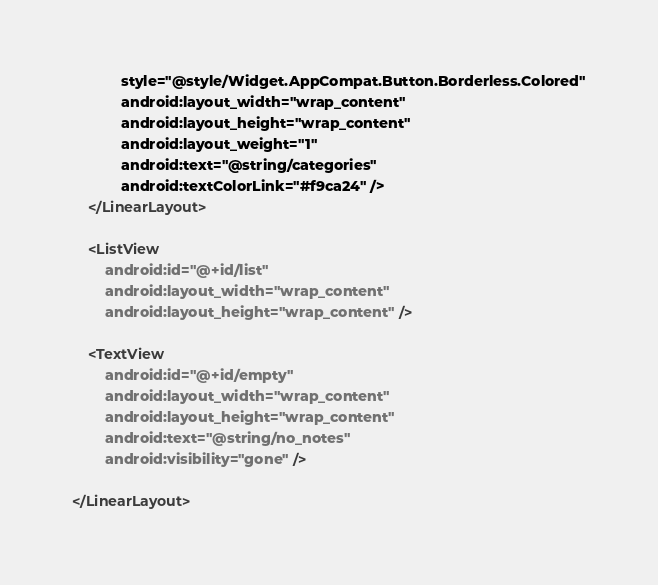<code> <loc_0><loc_0><loc_500><loc_500><_XML_>            style="@style/Widget.AppCompat.Button.Borderless.Colored"
            android:layout_width="wrap_content"
            android:layout_height="wrap_content"
            android:layout_weight="1"
            android:text="@string/categories"
            android:textColorLink="#f9ca24" />
    </LinearLayout>

    <ListView
        android:id="@+id/list"
        android:layout_width="wrap_content"
        android:layout_height="wrap_content" />

    <TextView
        android:id="@+id/empty"
        android:layout_width="wrap_content"
        android:layout_height="wrap_content"
        android:text="@string/no_notes"
        android:visibility="gone" />

</LinearLayout></code> 